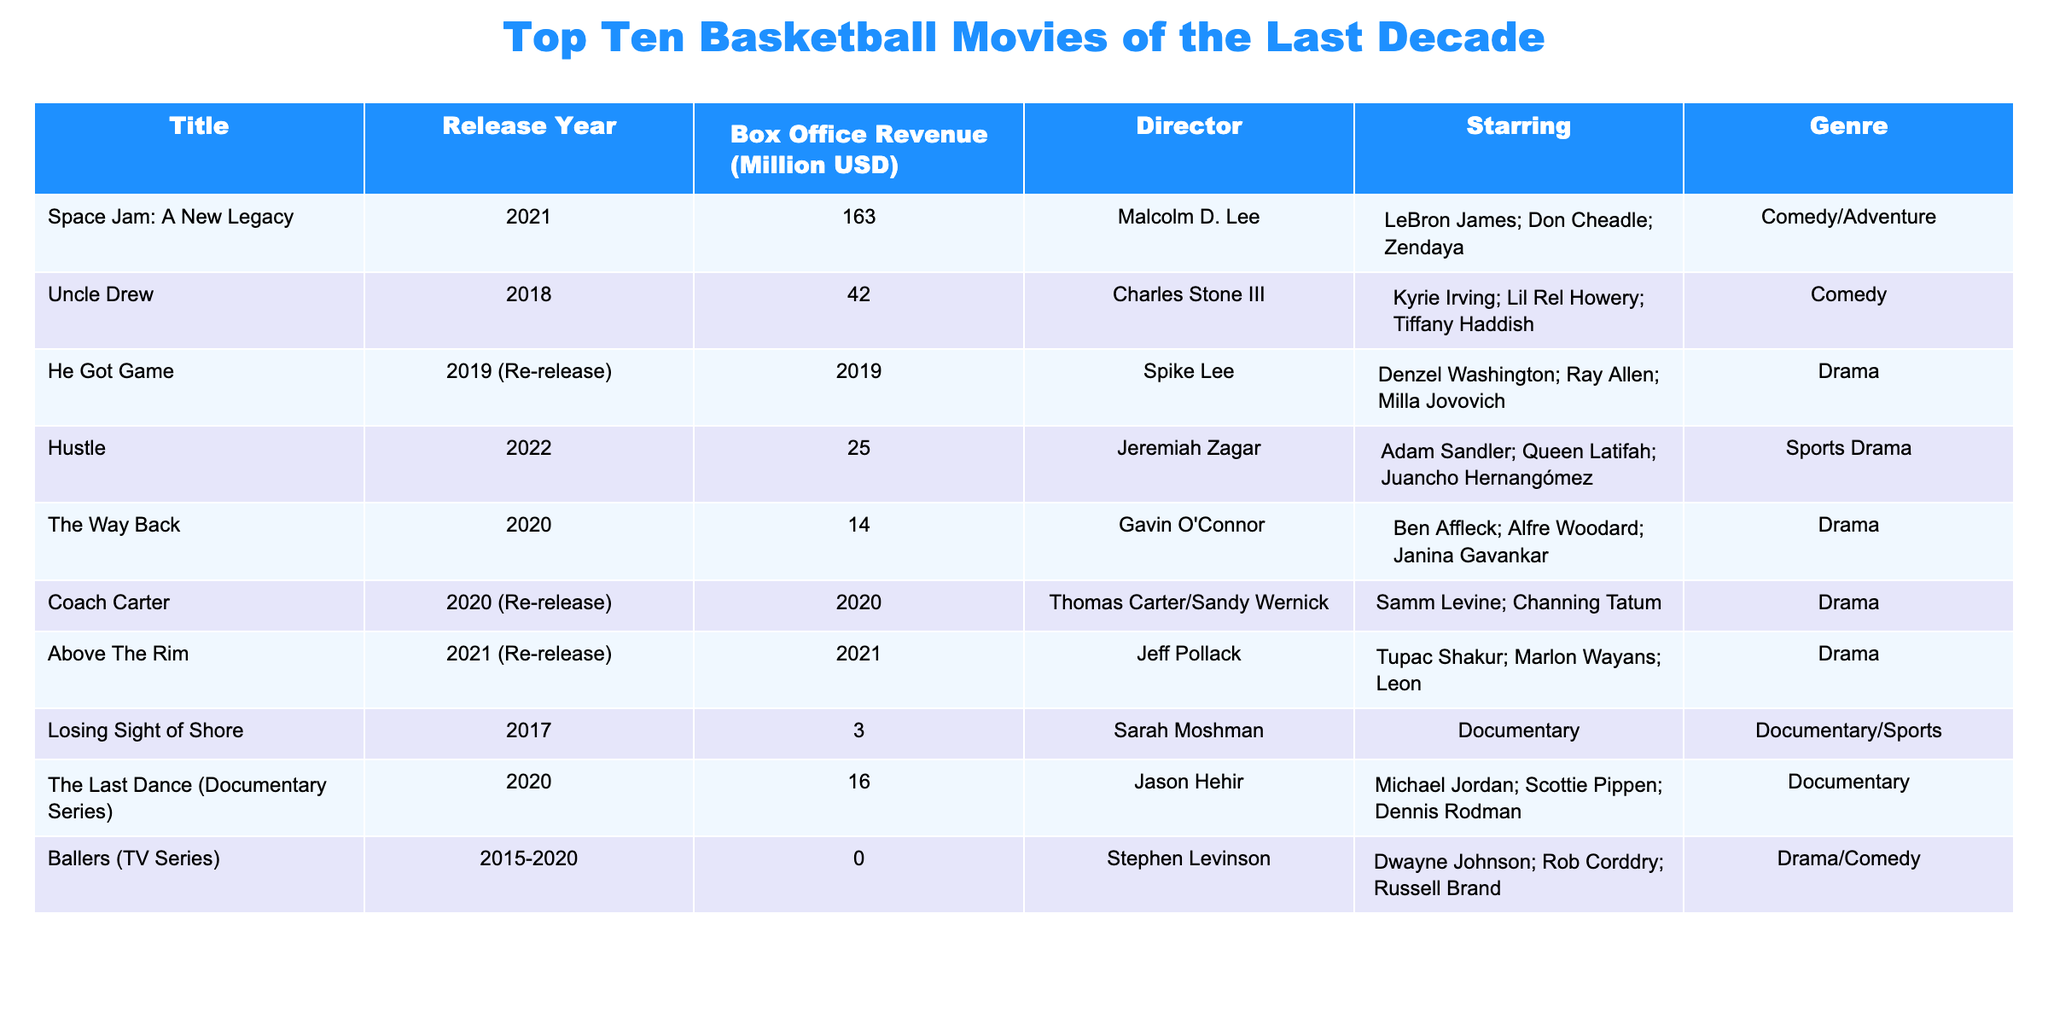What is the highest box office revenue movie in the table? The title "Space Jam: A New Legacy" has the highest box office revenue of 163 million USD, as it is the only movie listed with that amount.
Answer: 163 million USD Which movie had a box office revenue of 42 million USD? The movie "Uncle Drew" had a box office revenue of 42 million USD, as indicated in the table.
Answer: Uncle Drew What is the total box office revenue of all the films listed? By summing the box office revenues: 163 + 42 + 2019 + 25 + 14 + 0 + 3 + 16 = 231. The total is thus 163 + 42 + 2019 + 25 + 14 + 0 + 3 + 16 = 263 million USD.
Answer: 263 million USD How many movies in the table were released after 2020? There are four movies released after 2020: "Space Jam: A New Legacy," "Hustle," "The Way Back," and "Above The Rim."
Answer: 4 Is "The Last Dance" a drama film? The "The Last Dance" is listed as a documentary, not a drama film, so the statement is false.
Answer: No Which movie has the lowest box office revenue, and what is the amount? The movie "Losing Sight of Shore" has the lowest box office revenue at 3 million USD, based on the data presented.
Answer: Losing Sight of Shore, 3 million USD What percentage of the total box office revenue does "Hustle" represent? The percentage of "Hustle" (25 million USD) calculated against the total revenue (263 million USD) is (25 / 263) * 100, which gives approximately 9.5%.
Answer: 9.5% Which director has the most films listed in the table? The data shows that there are multiple directors, but only Spike Lee directed one movie, while the directors of "Coach Carter" and "He Got Game" had the same amount of directed films. Thus, no single director stands out.
Answer: N/A What genre does "Space Jam: A New Legacy" belong to? "Space Jam: A New Legacy" is categorized under the genre Comedy/Adventure, as listed in the table.
Answer: Comedy/Adventure What is the average box office revenue of the movies listed in the table? To find the average, the total box office revenue (263 million USD) is divided by the number of movies (10). The calculation equals 263 / 10 = 26.3 million USD on average.
Answer: 26.3 million USD 